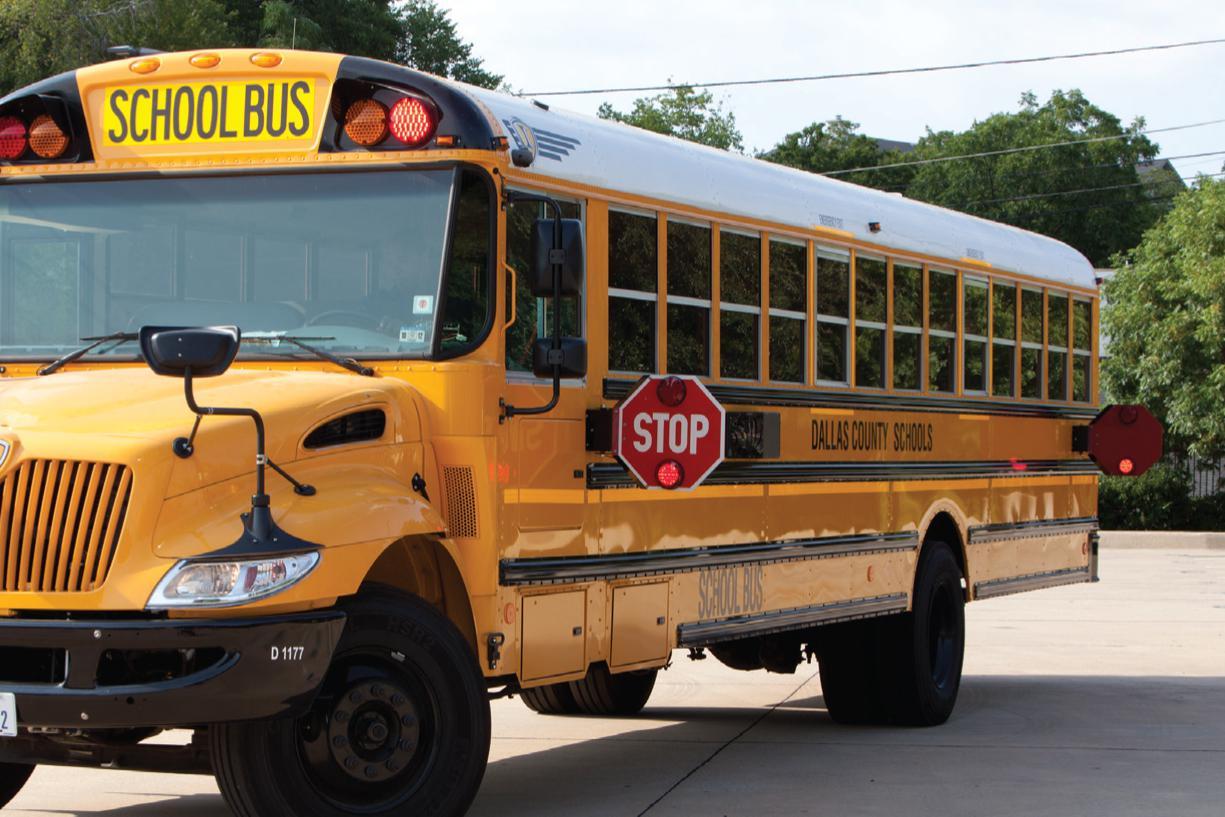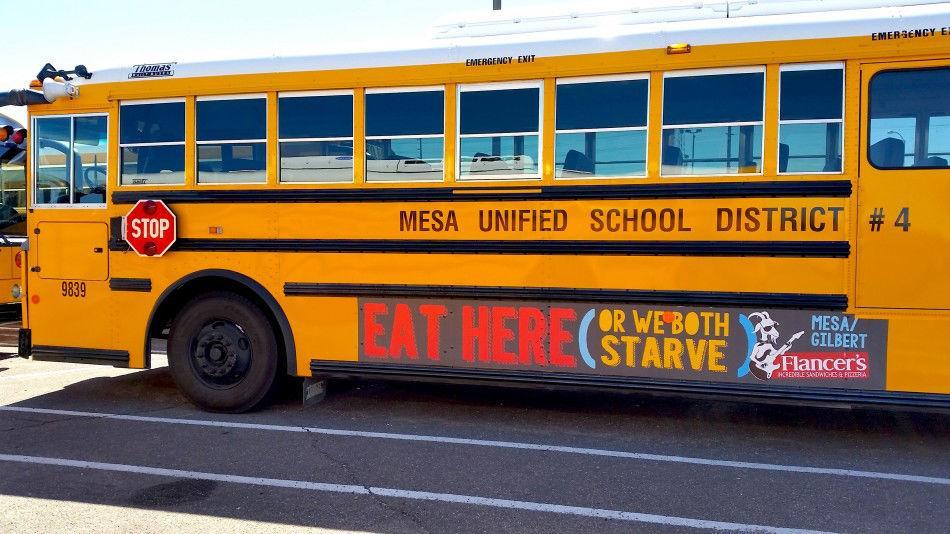The first image is the image on the left, the second image is the image on the right. Examine the images to the left and right. Is the description "At least one image shows the rear-facing tail end of a parked yellow bus, and no image shows a non-flat bus front." accurate? Answer yes or no. No. 